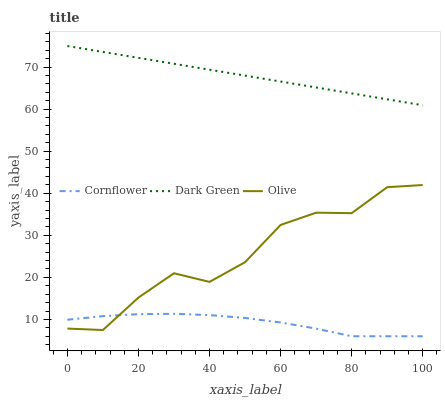Does Cornflower have the minimum area under the curve?
Answer yes or no. Yes. Does Dark Green have the maximum area under the curve?
Answer yes or no. Yes. Does Dark Green have the minimum area under the curve?
Answer yes or no. No. Does Cornflower have the maximum area under the curve?
Answer yes or no. No. Is Dark Green the smoothest?
Answer yes or no. Yes. Is Olive the roughest?
Answer yes or no. Yes. Is Cornflower the smoothest?
Answer yes or no. No. Is Cornflower the roughest?
Answer yes or no. No. Does Cornflower have the lowest value?
Answer yes or no. Yes. Does Dark Green have the lowest value?
Answer yes or no. No. Does Dark Green have the highest value?
Answer yes or no. Yes. Does Cornflower have the highest value?
Answer yes or no. No. Is Olive less than Dark Green?
Answer yes or no. Yes. Is Dark Green greater than Olive?
Answer yes or no. Yes. Does Cornflower intersect Olive?
Answer yes or no. Yes. Is Cornflower less than Olive?
Answer yes or no. No. Is Cornflower greater than Olive?
Answer yes or no. No. Does Olive intersect Dark Green?
Answer yes or no. No. 